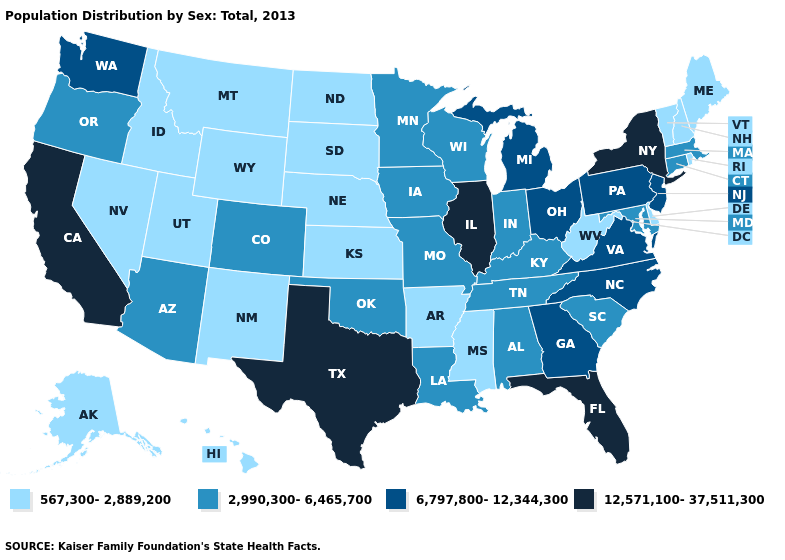Name the states that have a value in the range 6,797,800-12,344,300?
Quick response, please. Georgia, Michigan, New Jersey, North Carolina, Ohio, Pennsylvania, Virginia, Washington. Name the states that have a value in the range 6,797,800-12,344,300?
Write a very short answer. Georgia, Michigan, New Jersey, North Carolina, Ohio, Pennsylvania, Virginia, Washington. Does the first symbol in the legend represent the smallest category?
Write a very short answer. Yes. Does the map have missing data?
Give a very brief answer. No. What is the lowest value in the USA?
Give a very brief answer. 567,300-2,889,200. What is the value of Tennessee?
Give a very brief answer. 2,990,300-6,465,700. What is the lowest value in states that border Missouri?
Concise answer only. 567,300-2,889,200. Does Missouri have the lowest value in the USA?
Answer briefly. No. What is the value of Texas?
Concise answer only. 12,571,100-37,511,300. What is the lowest value in the South?
Write a very short answer. 567,300-2,889,200. Does North Dakota have a higher value than Rhode Island?
Concise answer only. No. Which states hav the highest value in the Northeast?
Write a very short answer. New York. What is the highest value in the USA?
Quick response, please. 12,571,100-37,511,300. What is the lowest value in states that border Alabama?
Keep it brief. 567,300-2,889,200. Does Arizona have the lowest value in the USA?
Write a very short answer. No. 